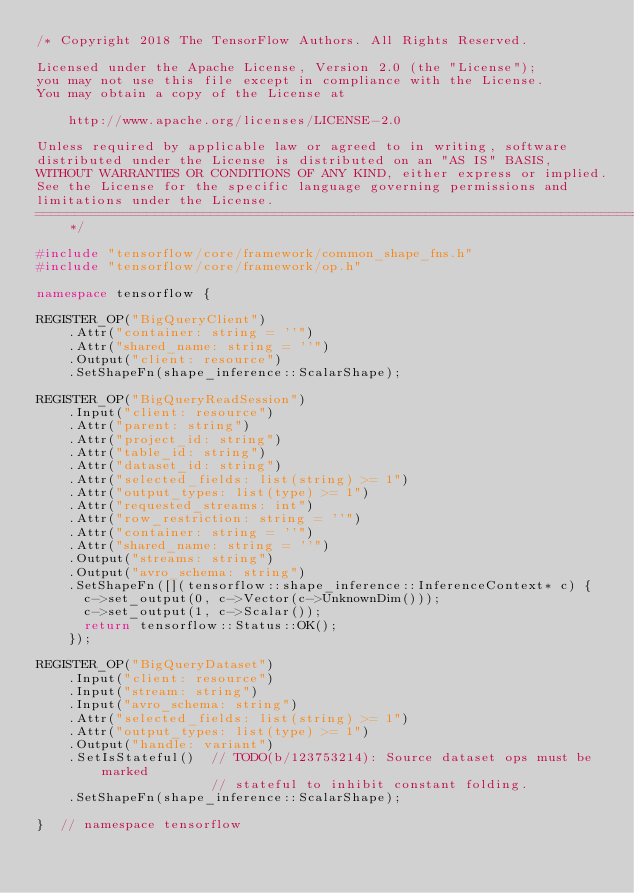Convert code to text. <code><loc_0><loc_0><loc_500><loc_500><_C++_>/* Copyright 2018 The TensorFlow Authors. All Rights Reserved.

Licensed under the Apache License, Version 2.0 (the "License");
you may not use this file except in compliance with the License.
You may obtain a copy of the License at

    http://www.apache.org/licenses/LICENSE-2.0

Unless required by applicable law or agreed to in writing, software
distributed under the License is distributed on an "AS IS" BASIS,
WITHOUT WARRANTIES OR CONDITIONS OF ANY KIND, either express or implied.
See the License for the specific language governing permissions and
limitations under the License.
==============================================================================*/

#include "tensorflow/core/framework/common_shape_fns.h"
#include "tensorflow/core/framework/op.h"

namespace tensorflow {

REGISTER_OP("BigQueryClient")
    .Attr("container: string = ''")
    .Attr("shared_name: string = ''")
    .Output("client: resource")
    .SetShapeFn(shape_inference::ScalarShape);

REGISTER_OP("BigQueryReadSession")
    .Input("client: resource")
    .Attr("parent: string")
    .Attr("project_id: string")
    .Attr("table_id: string")
    .Attr("dataset_id: string")
    .Attr("selected_fields: list(string) >= 1")
    .Attr("output_types: list(type) >= 1")
    .Attr("requested_streams: int")
    .Attr("row_restriction: string = ''")
    .Attr("container: string = ''")
    .Attr("shared_name: string = ''")
    .Output("streams: string")
    .Output("avro_schema: string")
    .SetShapeFn([](tensorflow::shape_inference::InferenceContext* c) {
      c->set_output(0, c->Vector(c->UnknownDim()));
      c->set_output(1, c->Scalar());
      return tensorflow::Status::OK();
    });

REGISTER_OP("BigQueryDataset")
    .Input("client: resource")
    .Input("stream: string")
    .Input("avro_schema: string")
    .Attr("selected_fields: list(string) >= 1")
    .Attr("output_types: list(type) >= 1")
    .Output("handle: variant")
    .SetIsStateful()  // TODO(b/123753214): Source dataset ops must be marked
                      // stateful to inhibit constant folding.
    .SetShapeFn(shape_inference::ScalarShape);

}  // namespace tensorflow
</code> 